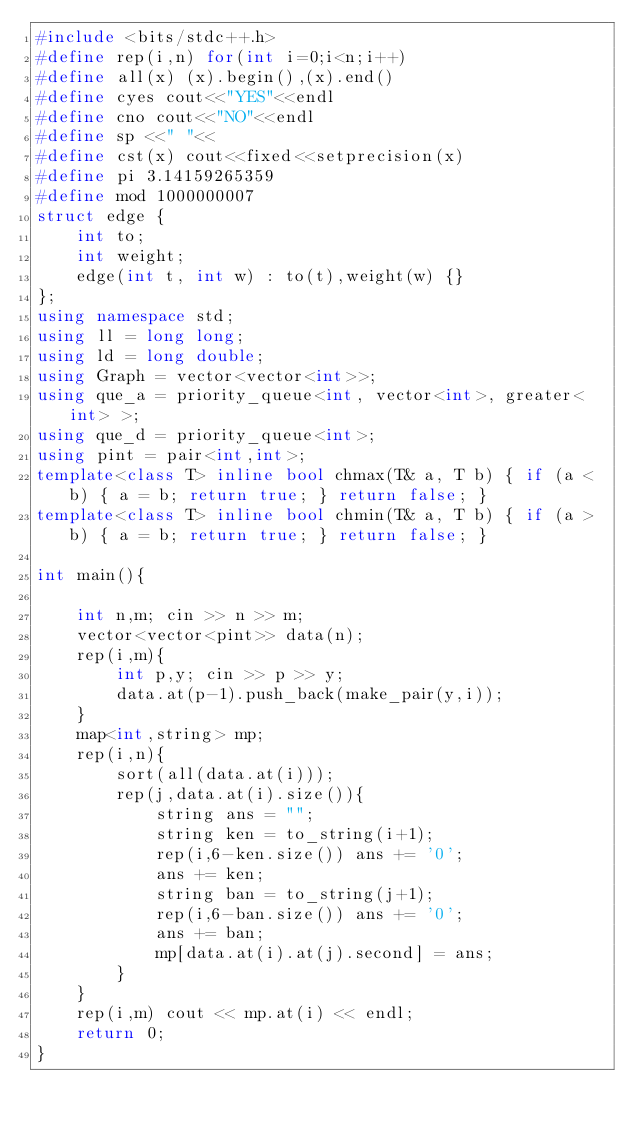<code> <loc_0><loc_0><loc_500><loc_500><_C++_>#include <bits/stdc++.h>
#define rep(i,n) for(int i=0;i<n;i++)
#define all(x) (x).begin(),(x).end()
#define cyes cout<<"YES"<<endl
#define cno cout<<"NO"<<endl
#define sp <<" "<<
#define cst(x) cout<<fixed<<setprecision(x)
#define pi 3.14159265359
#define mod 1000000007
struct edge {
    int to; 
    int weight;
    edge(int t, int w) : to(t),weight(w) {}
};
using namespace std;
using ll = long long;
using ld = long double;
using Graph = vector<vector<int>>;
using que_a = priority_queue<int, vector<int>, greater<int> >;
using que_d = priority_queue<int>;
using pint = pair<int,int>;
template<class T> inline bool chmax(T& a, T b) { if (a < b) { a = b; return true; } return false; }
template<class T> inline bool chmin(T& a, T b) { if (a > b) { a = b; return true; } return false; }

int main(){

    int n,m; cin >> n >> m;
    vector<vector<pint>> data(n);
    rep(i,m){
        int p,y; cin >> p >> y;
        data.at(p-1).push_back(make_pair(y,i));
    }
    map<int,string> mp;
    rep(i,n){
        sort(all(data.at(i)));
        rep(j,data.at(i).size()){
            string ans = "";
            string ken = to_string(i+1);
            rep(i,6-ken.size()) ans += '0';
            ans += ken;
            string ban = to_string(j+1);
            rep(i,6-ban.size()) ans += '0';
            ans += ban;
            mp[data.at(i).at(j).second] = ans;
        }
    }
    rep(i,m) cout << mp.at(i) << endl;
    return 0;
}
</code> 